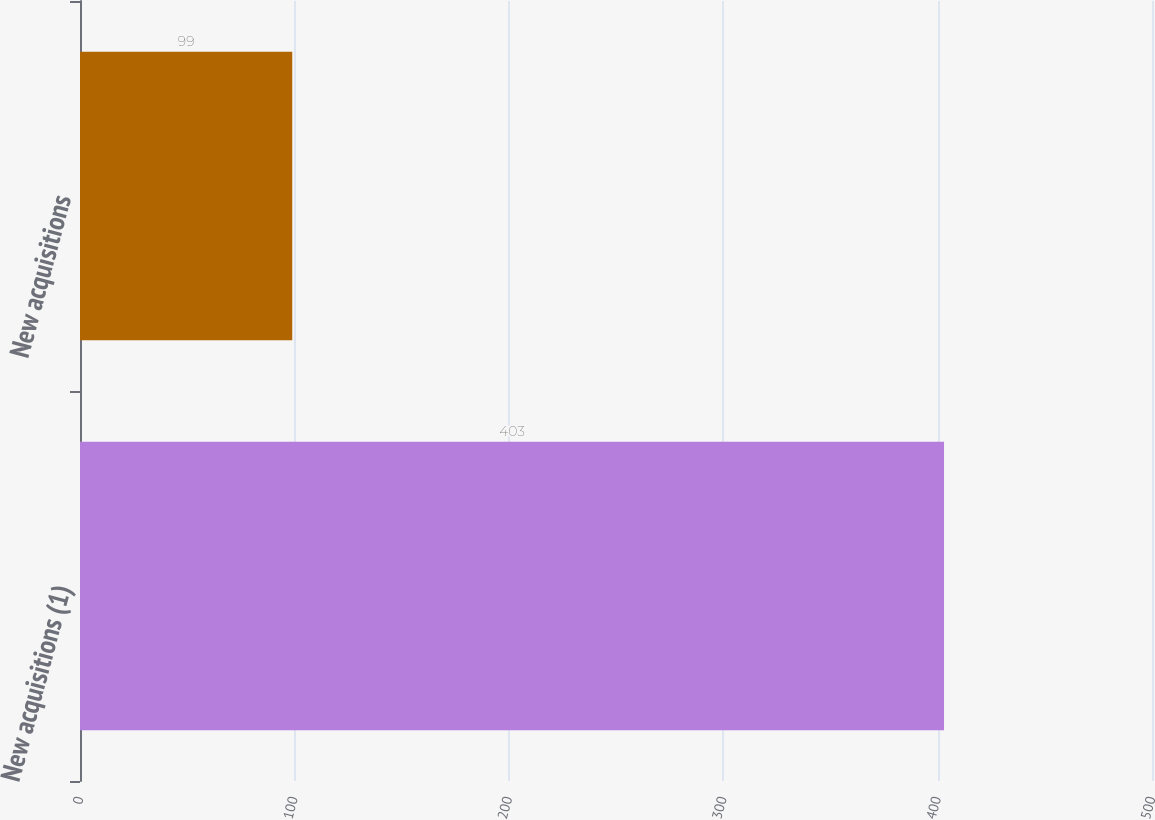Convert chart to OTSL. <chart><loc_0><loc_0><loc_500><loc_500><bar_chart><fcel>New acquisitions (1)<fcel>New acquisitions<nl><fcel>403<fcel>99<nl></chart> 